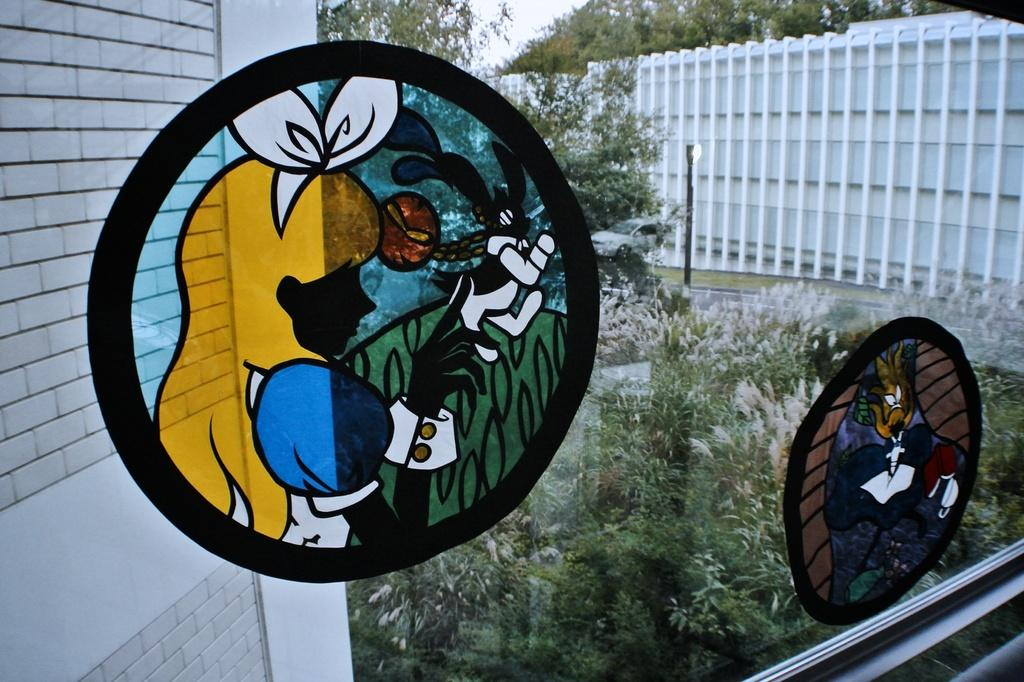What is inside the glass that is visible in the image? There is a painting in the glass in the image. What can be seen in the background of the image? Trees, a building, and the sky are visible in the background of the image. How does the painting in the glass comb its hair in the image? The painting in the glass does not have hair, and therefore cannot comb it. 